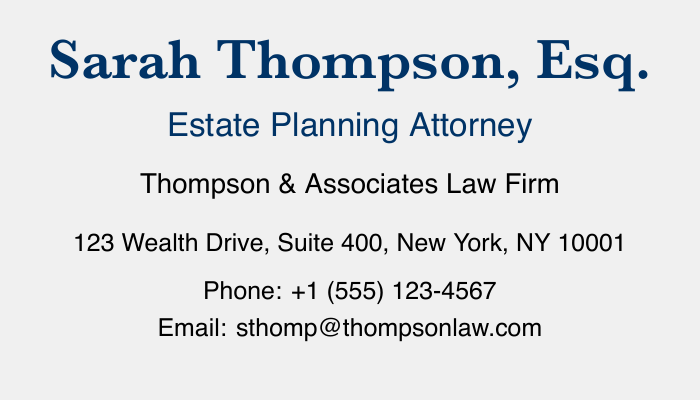What is the name of the attorney? The name of the attorney is prominently displayed at the top of the card.
Answer: Sarah Thompson, Esq What is the firm's name? The firm's name is listed below the attorney's title.
Answer: Thompson & Associates Law Firm Where is the office located? The address is provided underneath the firm name.
Answer: 123 Wealth Drive, Suite 400, New York, NY 10001 What is the phone number? The phone number is indicated clearly on the card.
Answer: +1 (555) 123-4567 Which email address is provided? The email address is listed towards the bottom of the card.
Answer: sthomp@thompsonlaw.com What service is related to "Asset Protection"? This is one of the key services listed on the card that deals with safeguarding assets.
Answer: Asset Protection How many key services are listed on the card? The number of key services can be counted from the relevant section.
Answer: Six What type of planning is mentioned for businesses? The specific type of planning for businesses is named in the services section.
Answer: Business Succession Planning What color is used for the attorney's name? The color of the attorney's name stands out in the document, indicating importance.
Answer: Dark blue 